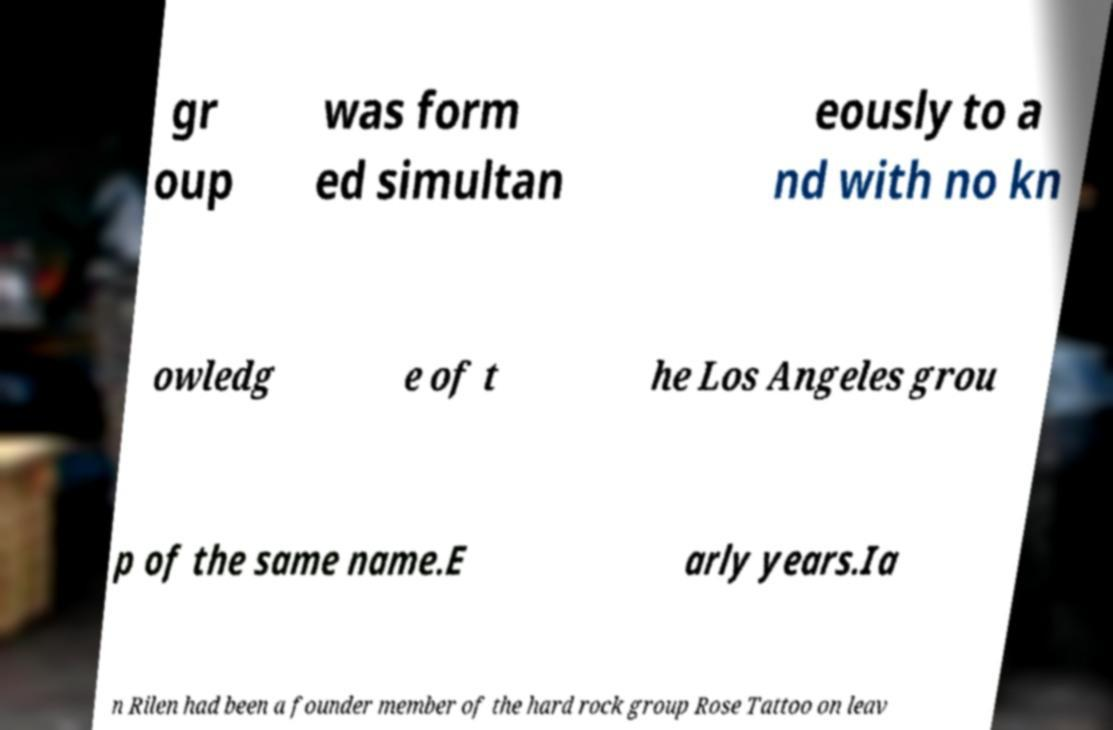What messages or text are displayed in this image? I need them in a readable, typed format. gr oup was form ed simultan eously to a nd with no kn owledg e of t he Los Angeles grou p of the same name.E arly years.Ia n Rilen had been a founder member of the hard rock group Rose Tattoo on leav 